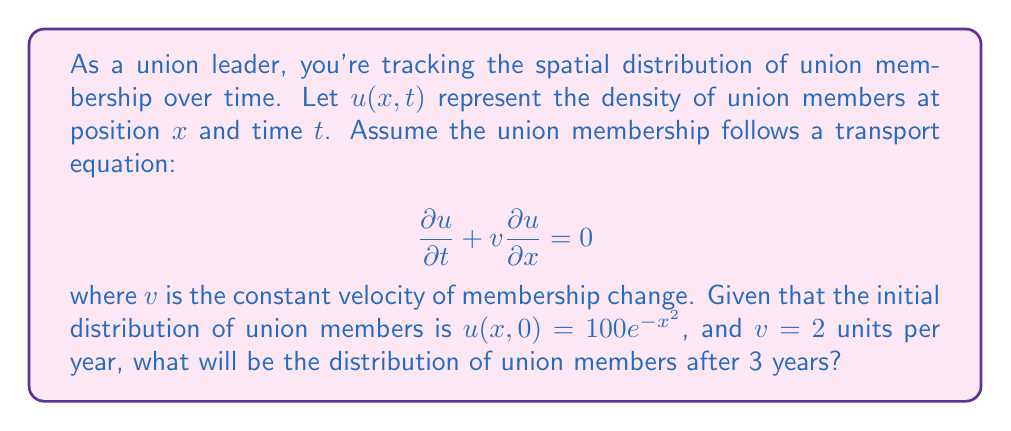What is the answer to this math problem? To solve this problem, we need to use the method of characteristics for the transport equation.

1) The general solution to the transport equation is:
   $$u(x,t) = f(x - vt)$$
   where $f$ is determined by the initial condition.

2) From the initial condition, we know that:
   $$u(x,0) = 100e^{-x^2} = f(x)$$

3) Therefore, the solution is:
   $$u(x,t) = 100e^{-(x-vt)^2}$$

4) Substituting the given values $v=2$ and $t=3$:
   $$u(x,3) = 100e^{-(x-2\cdot3)^2} = 100e^{-(x-6)^2}$$

This equation represents the distribution of union members after 3 years. The peak of the distribution has shifted 6 units to the right (as $v\cdot t = 2 \cdot 3 = 6$), but the shape and magnitude of the distribution remain the same due to the nature of the transport equation.
Answer: $u(x,3) = 100e^{-(x-6)^2}$ 